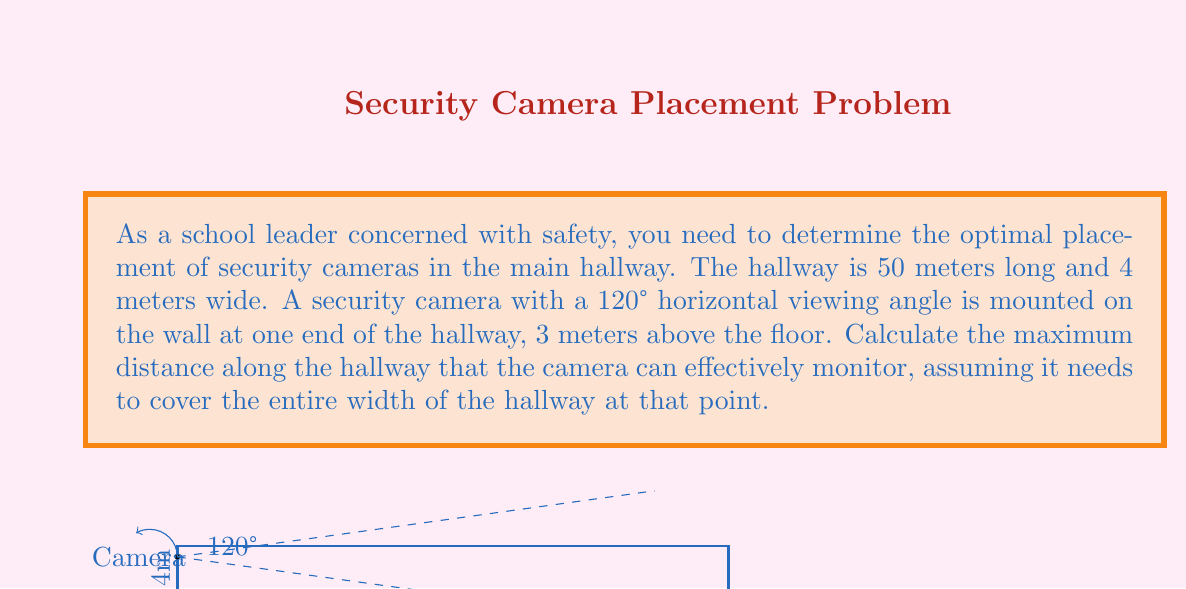Help me with this question. Let's approach this step-by-step:

1) First, we need to understand the geometry of the situation. The camera forms a right triangle with the floor and the far end of its viewing range.

2) We know the horizontal viewing angle of the camera is 120°. This means the angle between the camera's line of sight and the wall is 60° (half of 120°).

3) Let's call the maximum distance the camera can monitor $x$. We can use the tangent function to relate this to the width of the hallway:

   $$\tan(60°) = \frac{4}{x}$$

4) We know that $\tan(60°) = \sqrt{3}$. So we can rewrite our equation:

   $$\sqrt{3} = \frac{4}{x}$$

5) Solving for $x$:
   
   $$x = \frac{4}{\sqrt{3}} = \frac{4\sqrt{3}}{3}$$

6) Simplifying:

   $$x = \frac{4\sqrt{3}}{3} \approx 2.31 \text{ meters}$$

7) However, we need to consider the height of the camera. The actual distance along the floor will be greater due to the camera's elevation.

8) We can use the Pythagorean theorem to find this distance:

   $$d^2 = x^2 + 3^2$$

   Where $d$ is the distance along the floor and 3 is the height of the camera.

9) Substituting our value for $x$:

   $$d^2 = (\frac{4\sqrt{3}}{3})^2 + 3^2 = \frac{16 \cdot 3}{9} + 9 = \frac{16}{3} + 9 = \frac{43}{3}$$

10) Solving for $d$:

    $$d = \sqrt{\frac{43}{3}} \approx 3.78 \text{ meters}$$

Therefore, the camera can effectively monitor approximately 3.78 meters along the hallway while covering its entire width.
Answer: 3.78 meters 